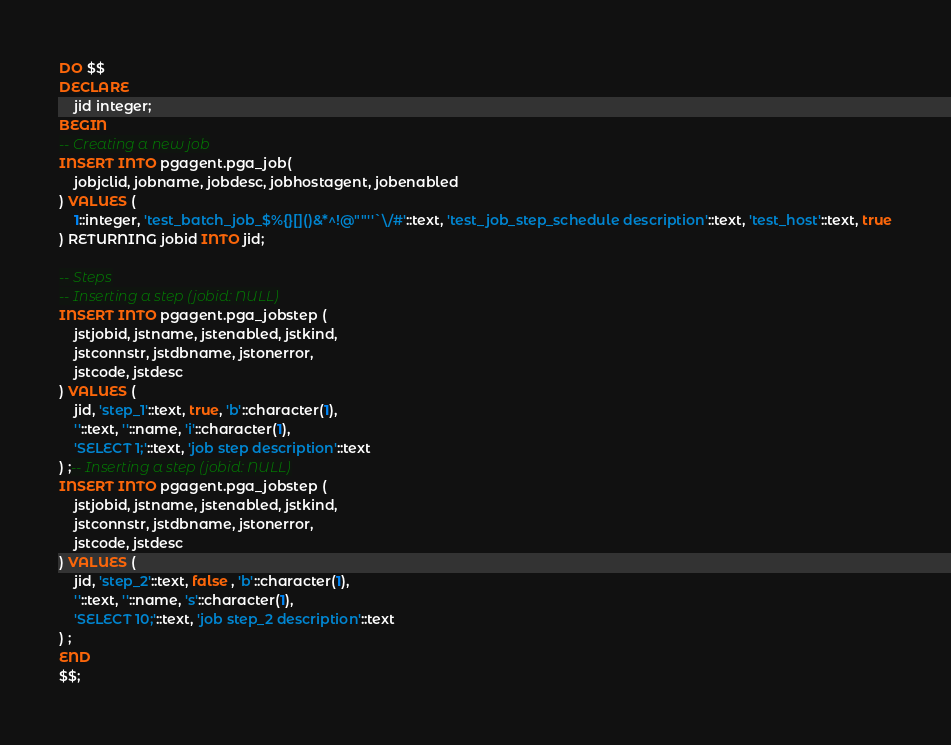<code> <loc_0><loc_0><loc_500><loc_500><_SQL_>DO $$
DECLARE
    jid integer;
BEGIN
-- Creating a new job
INSERT INTO pgagent.pga_job(
    jobjclid, jobname, jobdesc, jobhostagent, jobenabled
) VALUES (
    1::integer, 'test_batch_job_$%{}[]()&*^!@""''`\/#'::text, 'test_job_step_schedule description'::text, 'test_host'::text, true
) RETURNING jobid INTO jid;

-- Steps
-- Inserting a step (jobid: NULL)
INSERT INTO pgagent.pga_jobstep (
    jstjobid, jstname, jstenabled, jstkind,
    jstconnstr, jstdbname, jstonerror,
    jstcode, jstdesc
) VALUES (
    jid, 'step_1'::text, true, 'b'::character(1),
    ''::text, ''::name, 'i'::character(1),
    'SELECT 1;'::text, 'job step description'::text
) ;-- Inserting a step (jobid: NULL)
INSERT INTO pgagent.pga_jobstep (
    jstjobid, jstname, jstenabled, jstkind,
    jstconnstr, jstdbname, jstonerror,
    jstcode, jstdesc
) VALUES (
    jid, 'step_2'::text, false , 'b'::character(1),
    ''::text, ''::name, 's'::character(1),
    'SELECT 10;'::text, 'job step_2 description'::text
) ;
END
$$;
</code> 